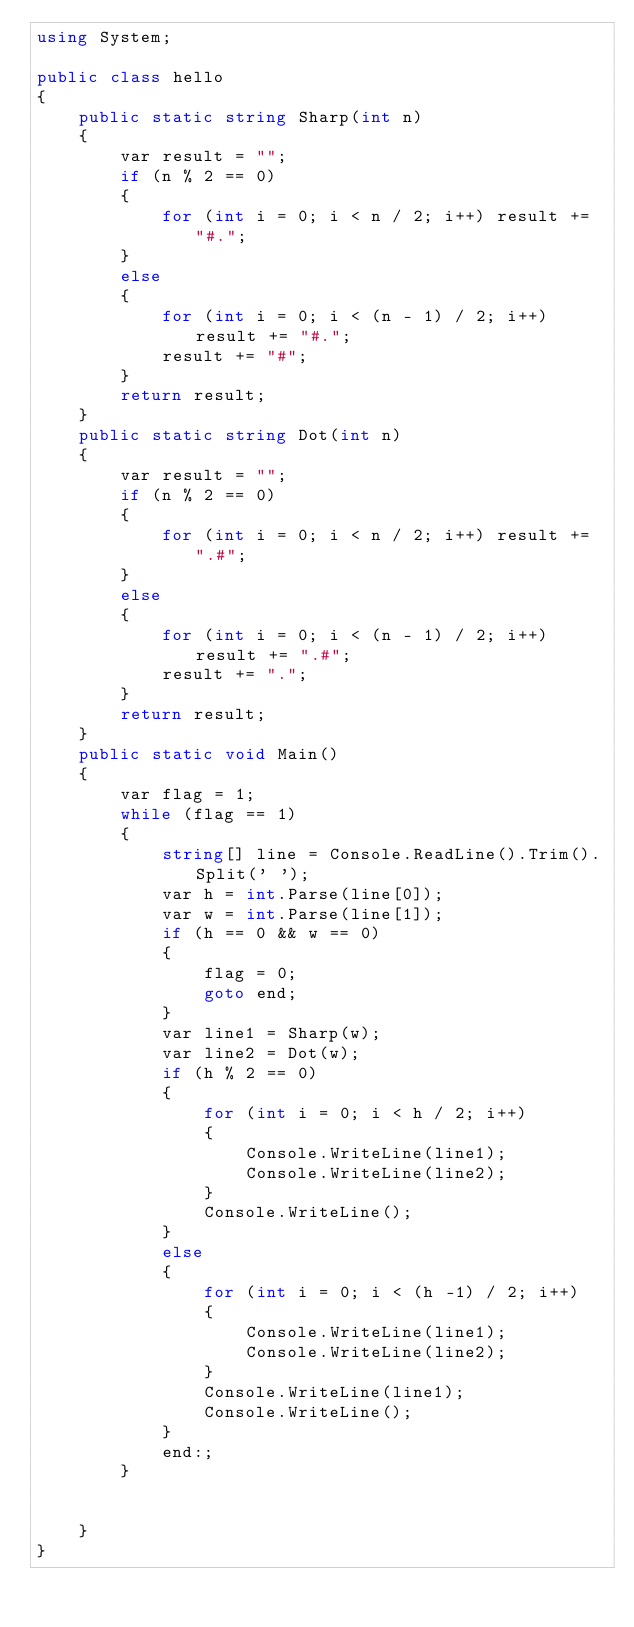<code> <loc_0><loc_0><loc_500><loc_500><_C#_>using System;

public class hello
{
    public static string Sharp(int n)
    {
        var result = "";
        if (n % 2 == 0)
        {
            for (int i = 0; i < n / 2; i++) result += "#.";
        }
        else
        {
            for (int i = 0; i < (n - 1) / 2; i++) result += "#.";
            result += "#";
        }
        return result;
    }
    public static string Dot(int n)
    {
        var result = "";
        if (n % 2 == 0)
        {
            for (int i = 0; i < n / 2; i++) result += ".#";
        }
        else
        {
            for (int i = 0; i < (n - 1) / 2; i++) result += ".#";
            result += ".";
        }
        return result;
    }
    public static void Main()
    {
        var flag = 1;
        while (flag == 1)
        {
            string[] line = Console.ReadLine().Trim().Split(' ');
            var h = int.Parse(line[0]);
            var w = int.Parse(line[1]);
            if (h == 0 && w == 0)
            {
                flag = 0;
                goto end;
            }
            var line1 = Sharp(w);
            var line2 = Dot(w);
            if (h % 2 == 0)
            {
                for (int i = 0; i < h / 2; i++)
                {
                    Console.WriteLine(line1);
                    Console.WriteLine(line2);
                }
                Console.WriteLine();
            }
            else
            {
                for (int i = 0; i < (h -1) / 2; i++)
                {
                    Console.WriteLine(line1);
                    Console.WriteLine(line2);
                }
                Console.WriteLine(line1);
                Console.WriteLine();
            }
            end:;
        }


    }
}</code> 